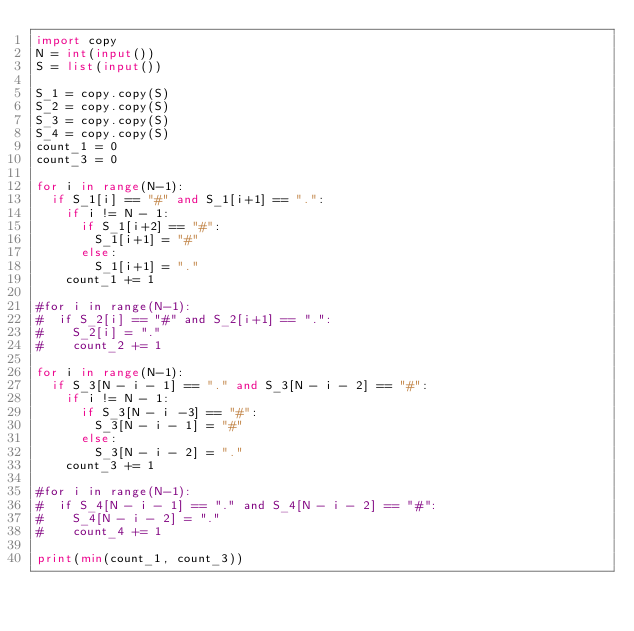<code> <loc_0><loc_0><loc_500><loc_500><_Python_>import copy
N = int(input())
S = list(input())
 
S_1 = copy.copy(S)
S_2 = copy.copy(S)
S_3 = copy.copy(S)
S_4 = copy.copy(S)
count_1 = 0
count_3 = 0

for i in range(N-1):
  if S_1[i] == "#" and S_1[i+1] == ".":
    if i != N - 1:
      if S_1[i+2] == "#":
        S_1[i+1] = "#"
      else:
        S_1[i+1] = "."
    count_1 += 1
    
#for i in range(N-1):
#  if S_2[i] == "#" and S_2[i+1] == ".":
#    S_2[i] = "."
#    count_2 += 1
    
for i in range(N-1):
  if S_3[N - i - 1] == "." and S_3[N - i - 2] == "#":
    if i != N - 1:
      if S_3[N - i -3] == "#":
        S_3[N - i - 1] = "#"
      else:
        S_3[N - i - 2] = "."
    count_3 += 1
    
#for i in range(N-1):
#  if S_4[N - i - 1] == "." and S_4[N - i - 2] == "#":
#    S_4[N - i - 2] = "."
#    count_4 += 1
    
print(min(count_1, count_3))</code> 